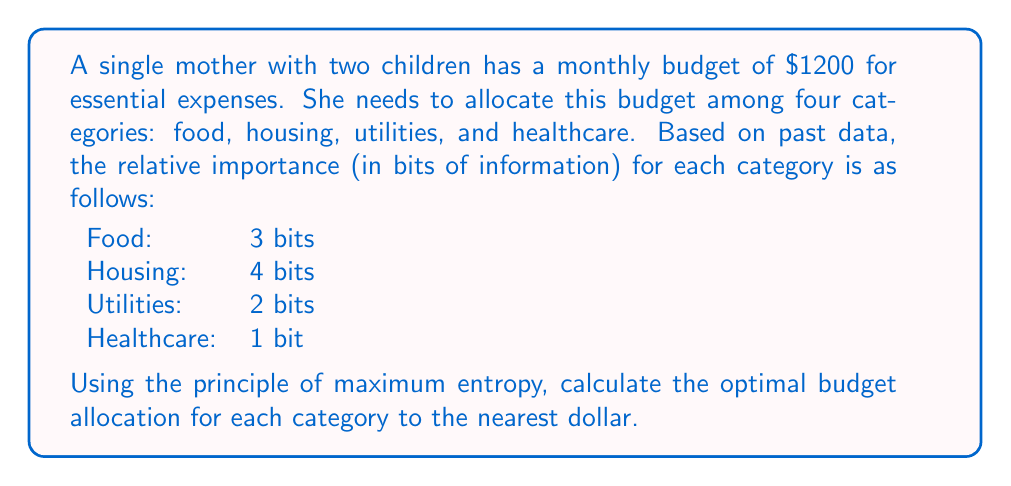What is the answer to this math problem? To solve this problem, we'll use the principle of maximum entropy from information theory. This principle suggests that the most unbiased distribution of resources is one that maximizes entropy while satisfying the given constraints.

Step 1: Calculate the total information content
Total bits = 3 + 4 + 2 + 1 = 10 bits

Step 2: Calculate the proportion for each category
Let $p_i$ be the proportion for category $i$:

$p_{\text{food}} = \frac{3}{10}$
$p_{\text{housing}} = \frac{4}{10}$
$p_{\text{utilities}} = \frac{2}{10}$
$p_{\text{healthcare}} = \frac{1}{10}$

Step 3: Calculate the budget allocation
For each category $i$, the allocation $A_i$ is:

$A_i = p_i \times \text{Total Budget}$

$A_{\text{food}} = \frac{3}{10} \times 1200 = 360$
$A_{\text{housing}} = \frac{4}{10} \times 1200 = 480$
$A_{\text{utilities}} = \frac{2}{10} \times 1200 = 240$
$A_{\text{healthcare}} = \frac{1}{10} \times 1200 = 120$

Step 4: Round to the nearest dollar
Food: $360
Housing: $480
Utilities: $240
Healthcare: $120

This allocation maximizes the entropy of the distribution, ensuring the most unbiased distribution of the limited resources based on the given importance of each category.
Answer: The optimal budget allocation to the nearest dollar is:
Food: $360
Housing: $480
Utilities: $240
Healthcare: $120 